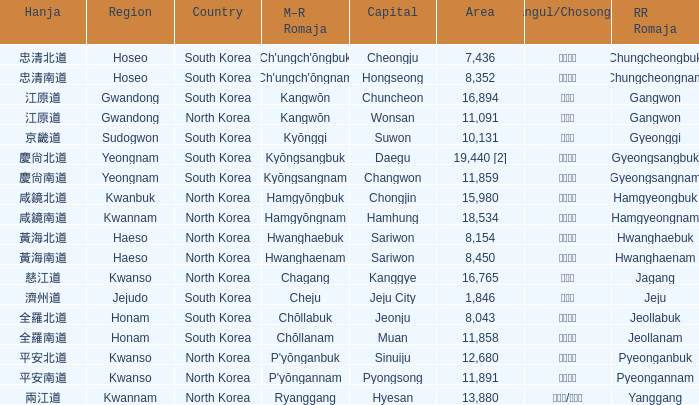Which country has a city with a Hanja of 平安北道? North Korea. 